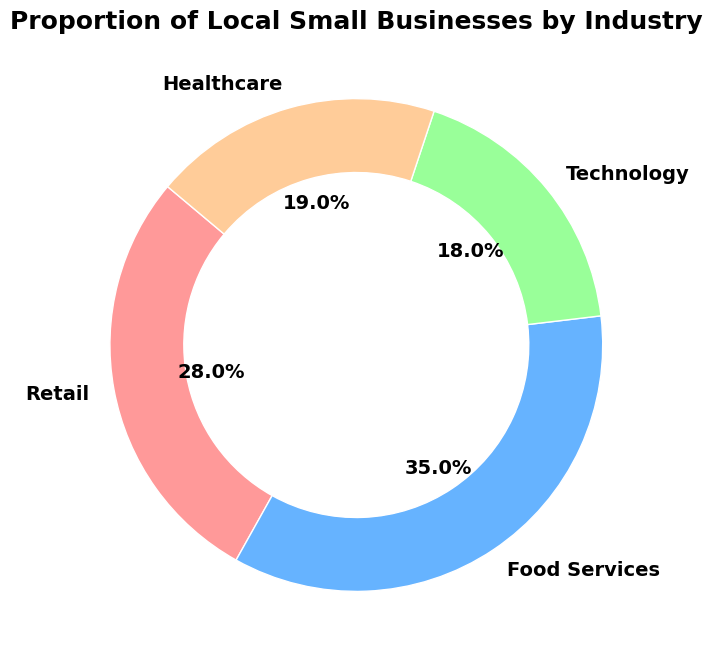what is the most common industry among local small businesses? The figure's percentages are 28%, 35%, 18%, and 19%. 35% is the highest, representing Food Services.
Answer: Food Services which two industries make up more than 50% of local small businesses combined? Summing up each pair, Retail (28%) + Food Services (35%) = 63%; Technology (18%) + Healthcare (19%) = 37%; others are below 50%.
Answer: Retail and Food Services which industry has the smallest proportion of local small businesses? The pie chart shows proportions: Retail 28%, Food Services 35%, Technology 18%, Healthcare 19%, so Technology is the smallest.
Answer: Technology how do the proportions of Healthcare and Technology compare? Healthcare is 19%, and Technology is 18%. Comparing these, Healthcare has a slightly higher proportion.
Answer: Healthcare has a slightly higher proportion What proportion of local small businesses are either in Retail or Healthcare? Adding Retail (28%) and Healthcare (19%) totals 28 + 19 = 47%.
Answer: 47% what is the difference in proportion between the industry with the highest and lowest small businesses? The highest is Food Services at 35%, and the lowest is Technology at 18%. The difference is 35 - 18 = 17%.
Answer: 17% Among Retail and Technology, which industry has a greater proportion of local small businesses, and by how much? Retail is 28%, and Technology is 18%. 28 - 18 = 10, so Retail is greater by 10%.
Answer: Retail by 10% If a new industry with 10% of small businesses were added, what would be the new proportion for Food Services? Originally, Food Services is 35% of 100%. With a new 10% industry, the total becomes 110%. The new proportion of Food Services: (35/110)*100 = 31.8%.
Answer: 31.8% What is the average proportion of all four industries? The proportions are 28%, 35%, 18%, and 19%. Summing these up: 28 + 35 + 18 + 19 = 100. Dividing by 4: 100/4 = 25%.
Answer: 25% Which industry proportion is closest to the average of all industries? The average is 25%. The proportions are Retail 28%, Food Services 35%, Technology 18%, Healthcare 19%. 28% is closest to 25%.
Answer: Retail 